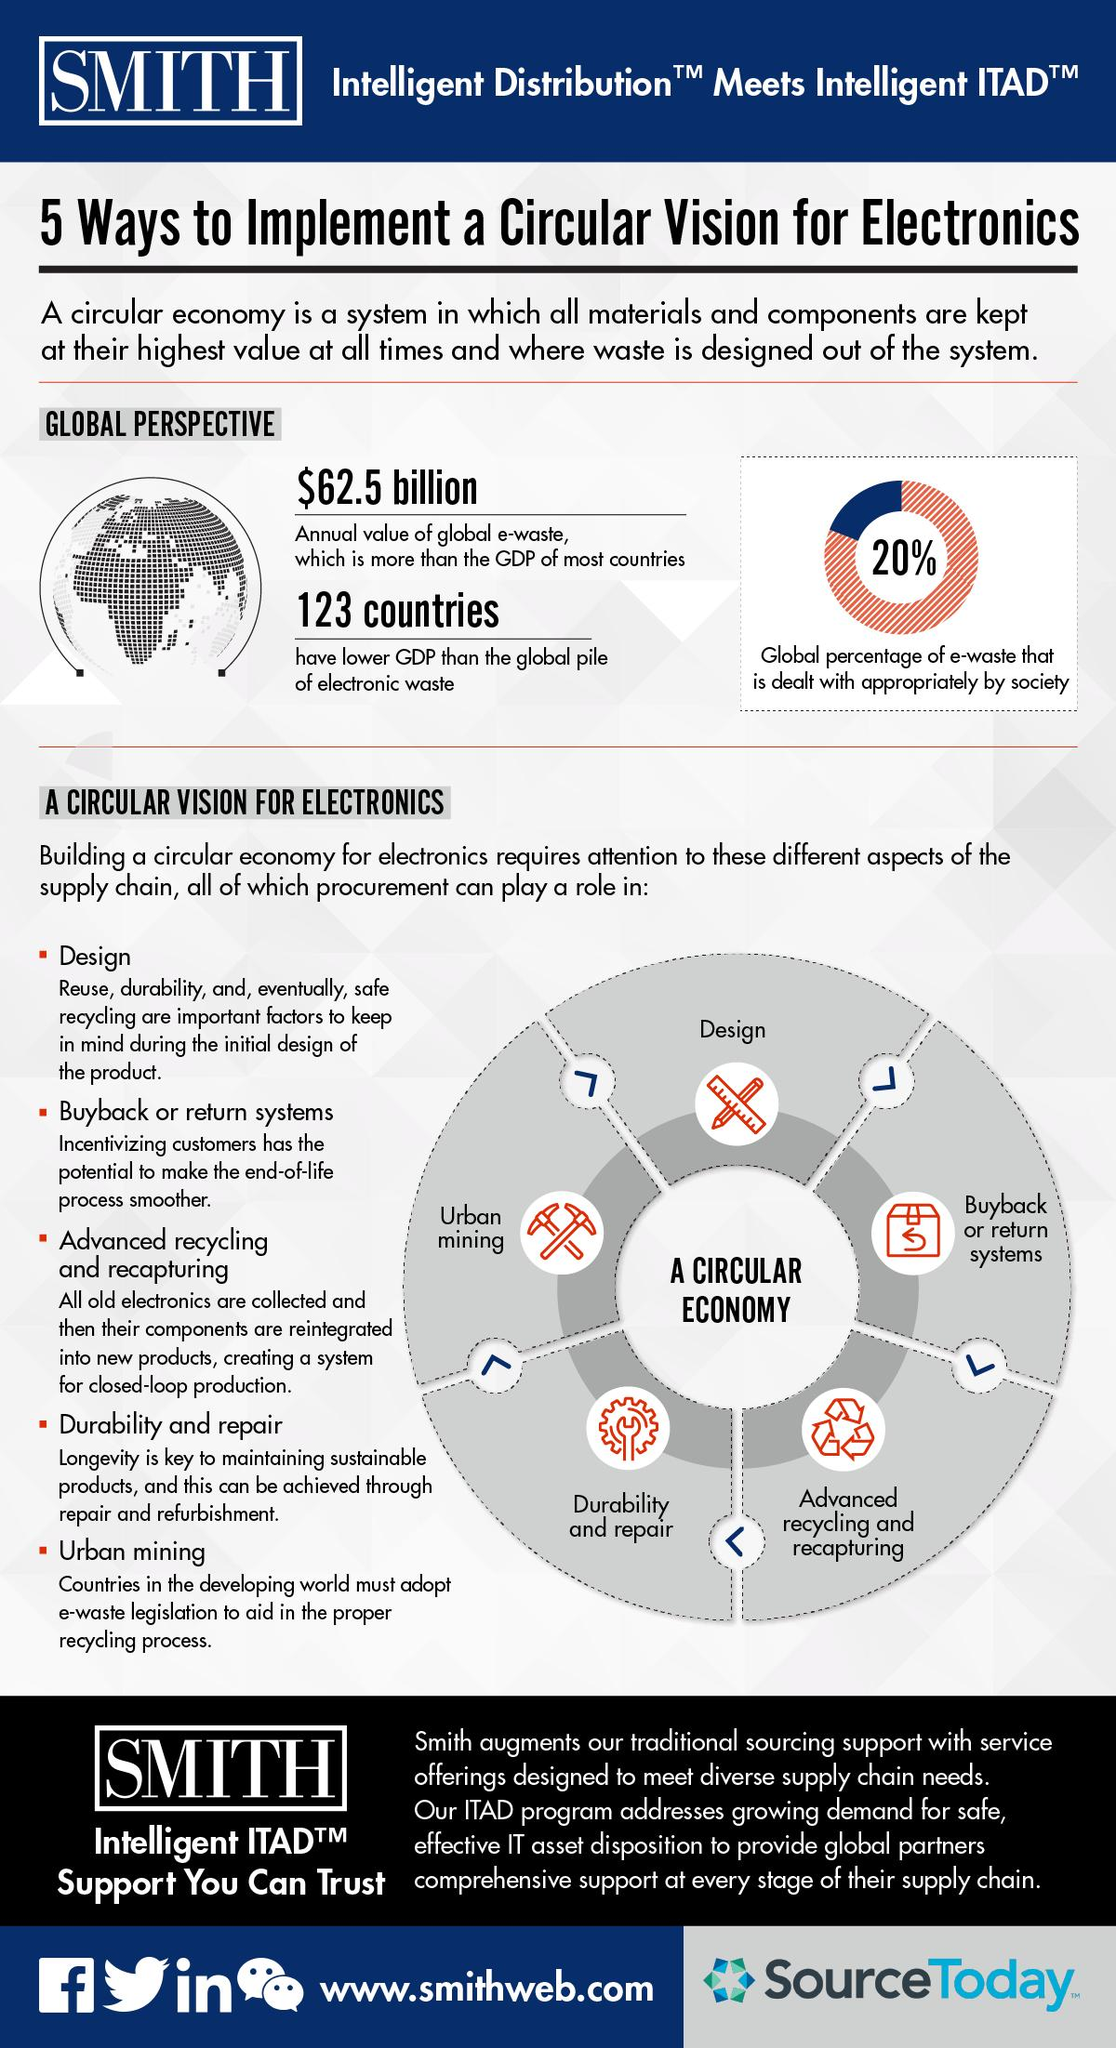Indicate a few pertinent items in this graphic. In 2021, it was reported that an alarming 80% of global e-waste is not being dealt with appropriately by society. The global e-waste is valued at approximately $62.5 billion per year. 